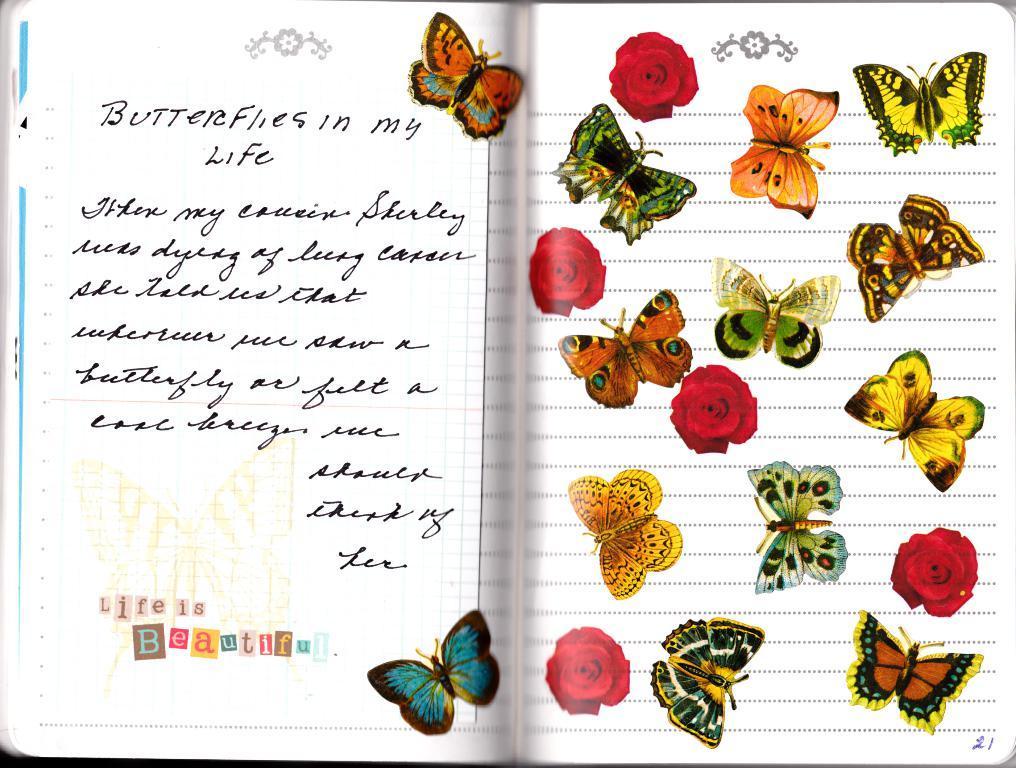Please provide a concise description of this image. In this picture we can see a book and on this book we can see some text and stickers of butterflies and flowers. 